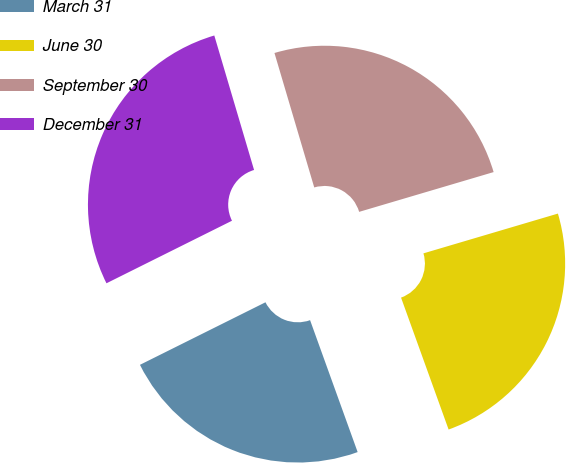<chart> <loc_0><loc_0><loc_500><loc_500><pie_chart><fcel>March 31<fcel>June 30<fcel>September 30<fcel>December 31<nl><fcel>23.15%<fcel>24.07%<fcel>25.0%<fcel>27.78%<nl></chart> 